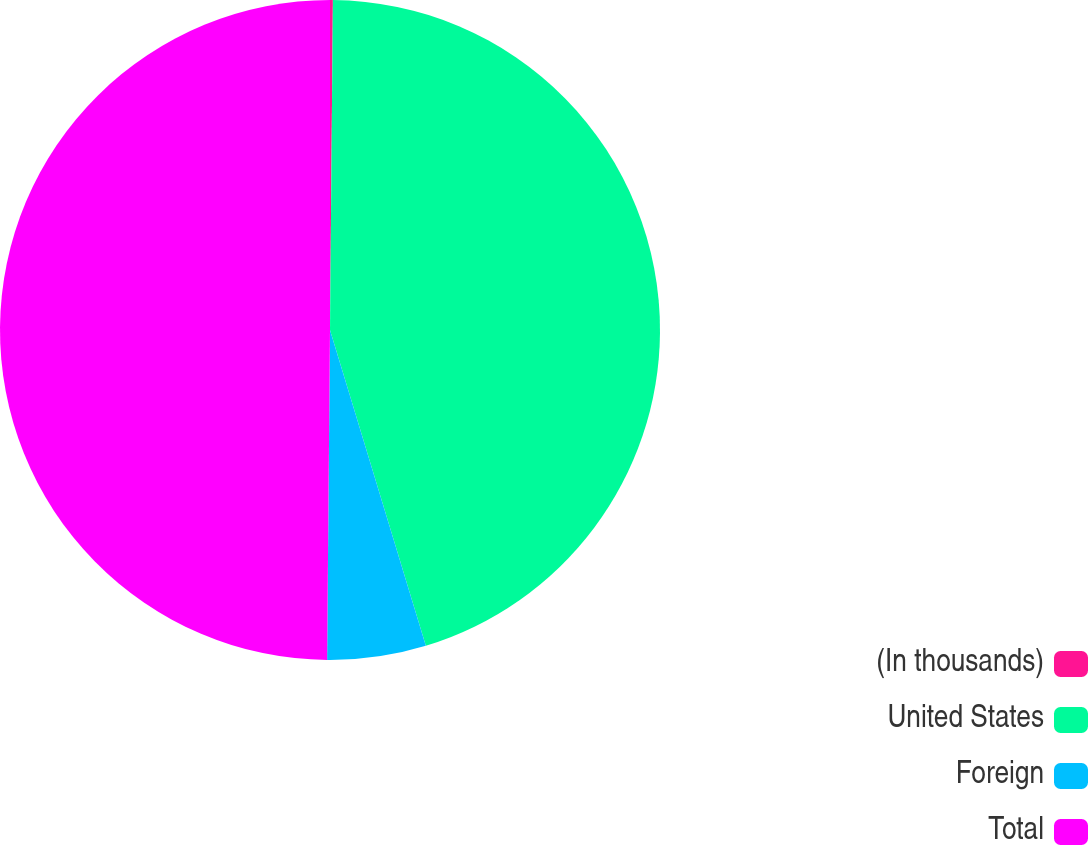Convert chart to OTSL. <chart><loc_0><loc_0><loc_500><loc_500><pie_chart><fcel>(In thousands)<fcel>United States<fcel>Foreign<fcel>Total<nl><fcel>0.14%<fcel>45.17%<fcel>4.83%<fcel>49.86%<nl></chart> 